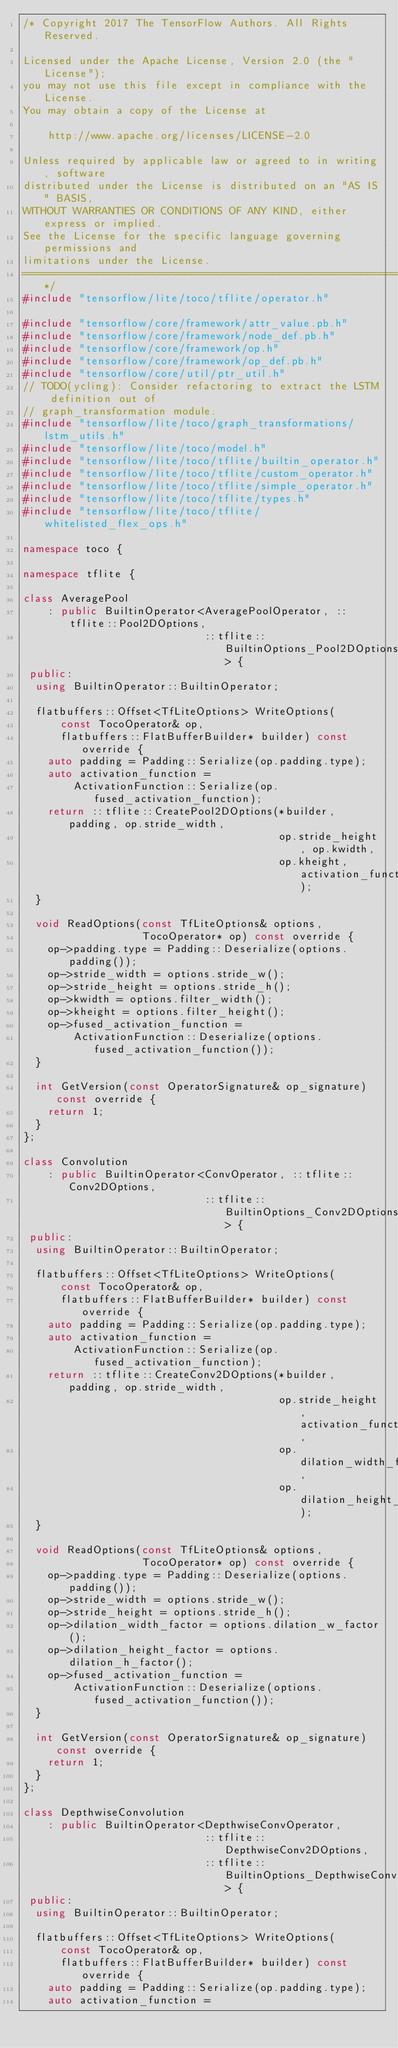Convert code to text. <code><loc_0><loc_0><loc_500><loc_500><_C++_>/* Copyright 2017 The TensorFlow Authors. All Rights Reserved.

Licensed under the Apache License, Version 2.0 (the "License");
you may not use this file except in compliance with the License.
You may obtain a copy of the License at

    http://www.apache.org/licenses/LICENSE-2.0

Unless required by applicable law or agreed to in writing, software
distributed under the License is distributed on an "AS IS" BASIS,
WITHOUT WARRANTIES OR CONDITIONS OF ANY KIND, either express or implied.
See the License for the specific language governing permissions and
limitations under the License.
==============================================================================*/
#include "tensorflow/lite/toco/tflite/operator.h"

#include "tensorflow/core/framework/attr_value.pb.h"
#include "tensorflow/core/framework/node_def.pb.h"
#include "tensorflow/core/framework/op.h"
#include "tensorflow/core/framework/op_def.pb.h"
#include "tensorflow/core/util/ptr_util.h"
// TODO(ycling): Consider refactoring to extract the LSTM definition out of
// graph_transformation module.
#include "tensorflow/lite/toco/graph_transformations/lstm_utils.h"
#include "tensorflow/lite/toco/model.h"
#include "tensorflow/lite/toco/tflite/builtin_operator.h"
#include "tensorflow/lite/toco/tflite/custom_operator.h"
#include "tensorflow/lite/toco/tflite/simple_operator.h"
#include "tensorflow/lite/toco/tflite/types.h"
#include "tensorflow/lite/toco/tflite/whitelisted_flex_ops.h"

namespace toco {

namespace tflite {

class AveragePool
    : public BuiltinOperator<AveragePoolOperator, ::tflite::Pool2DOptions,
                             ::tflite::BuiltinOptions_Pool2DOptions> {
 public:
  using BuiltinOperator::BuiltinOperator;

  flatbuffers::Offset<TfLiteOptions> WriteOptions(
      const TocoOperator& op,
      flatbuffers::FlatBufferBuilder* builder) const override {
    auto padding = Padding::Serialize(op.padding.type);
    auto activation_function =
        ActivationFunction::Serialize(op.fused_activation_function);
    return ::tflite::CreatePool2DOptions(*builder, padding, op.stride_width,
                                         op.stride_height, op.kwidth,
                                         op.kheight, activation_function);
  }

  void ReadOptions(const TfLiteOptions& options,
                   TocoOperator* op) const override {
    op->padding.type = Padding::Deserialize(options.padding());
    op->stride_width = options.stride_w();
    op->stride_height = options.stride_h();
    op->kwidth = options.filter_width();
    op->kheight = options.filter_height();
    op->fused_activation_function =
        ActivationFunction::Deserialize(options.fused_activation_function());
  }

  int GetVersion(const OperatorSignature& op_signature) const override {
    return 1;
  }
};

class Convolution
    : public BuiltinOperator<ConvOperator, ::tflite::Conv2DOptions,
                             ::tflite::BuiltinOptions_Conv2DOptions> {
 public:
  using BuiltinOperator::BuiltinOperator;

  flatbuffers::Offset<TfLiteOptions> WriteOptions(
      const TocoOperator& op,
      flatbuffers::FlatBufferBuilder* builder) const override {
    auto padding = Padding::Serialize(op.padding.type);
    auto activation_function =
        ActivationFunction::Serialize(op.fused_activation_function);
    return ::tflite::CreateConv2DOptions(*builder, padding, op.stride_width,
                                         op.stride_height, activation_function,
                                         op.dilation_width_factor,
                                         op.dilation_height_factor);
  }

  void ReadOptions(const TfLiteOptions& options,
                   TocoOperator* op) const override {
    op->padding.type = Padding::Deserialize(options.padding());
    op->stride_width = options.stride_w();
    op->stride_height = options.stride_h();
    op->dilation_width_factor = options.dilation_w_factor();
    op->dilation_height_factor = options.dilation_h_factor();
    op->fused_activation_function =
        ActivationFunction::Deserialize(options.fused_activation_function());
  }

  int GetVersion(const OperatorSignature& op_signature) const override {
    return 1;
  }
};

class DepthwiseConvolution
    : public BuiltinOperator<DepthwiseConvOperator,
                             ::tflite::DepthwiseConv2DOptions,
                             ::tflite::BuiltinOptions_DepthwiseConv2DOptions> {
 public:
  using BuiltinOperator::BuiltinOperator;

  flatbuffers::Offset<TfLiteOptions> WriteOptions(
      const TocoOperator& op,
      flatbuffers::FlatBufferBuilder* builder) const override {
    auto padding = Padding::Serialize(op.padding.type);
    auto activation_function =</code> 